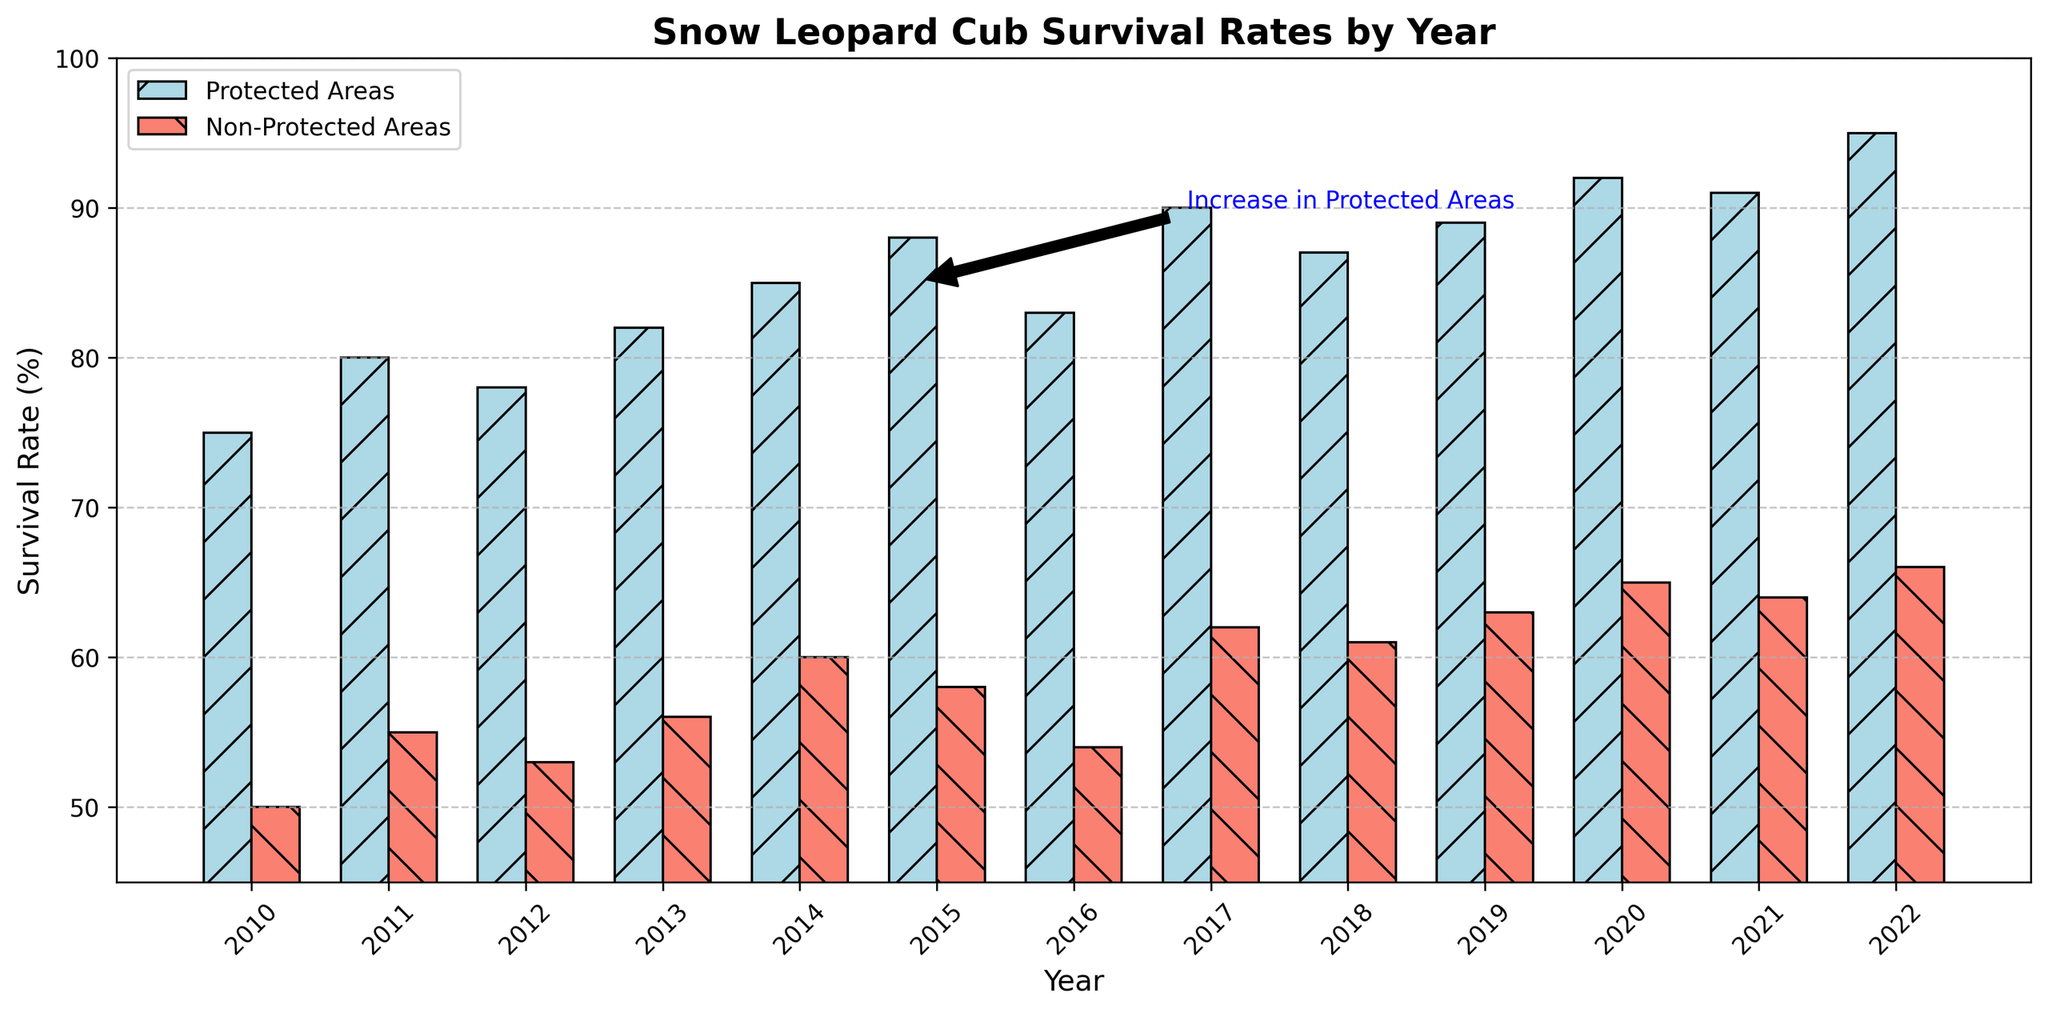What is the survival rate of snow leopard cubs in protected areas in 2015? Look at the bar that represents protected areas for the year 2015. The height of the bar indicates the survival rate.
Answer: 88 How much higher is the survival rate in protected areas compared to non-protected areas in 2022? Find the survival rates for both protected and non-protected areas in 2022. Subtract the non-protected rate from the protected rate to find the difference. 95 (protected) - 66 (non-protected) = 29
Answer: 29 Identify the year with the highest survival rate in non-protected areas. Compare the heights of the bars for non-protected areas across all years. The tallest bar corresponds to the highest survival rate.
Answer: 2022 What is the average survival rate in non-protected areas from 2010 to 2015? Sum the survival rates in non-protected areas for the years 2010 through 2015, then divide by the number of years (6). (50 + 55 + 53 + 56 + 60 + 58) / 6 = 55.333
Answer: 55.33 Which year saw the greatest increase in survival rate in protected areas compared to the previous year? Calculate the year-on-year differences in survival rates for protected areas and identify the year with the largest increase. (80-75=5, 78-80=-2, 82-78=4, 85-82=3, 88-85=3, 83-88=-5, 90-83=7, 87-90=-3, 89-87=2, 92-89=3, 91-92=-1, 95-91=4). The greatest increase is 7, which happened in 2017.
Answer: 2017 What visual element indicates general trends in the data? Identify the components such as bars, colors, and annotations that help illustrate trends over the years. The height of the bars indicates survival rates, and colors differentiate between protected and non-protected areas.
Answer: Bar height How does the annotation contribute to interpreting the data? Discuss the purpose of the annotation within the context of the chart. The annotation highlights the overall increase in survival rates in protected areas, drawing attention to a key trend.
Answer: Highlights key trend Compare the survival rates in 2010 and 2020 for protected areas. By how much did it change? Find the survival rates for protected areas in 2010 and 2020. Subtract the survival rate in 2010 from the rate in 2020. 92 (2020) - 75 (2010) = 17
Answer: 17 In which year did non-protected areas have the lowest survival rate? Identify the year with the shortest bar for non-protected areas, indicating the lowest survival rate.
Answer: 2010 What pattern can be observed from the trend lines of both protected and non-protected areas? Describe the general direction the bars take over time for both categories to deduce patterns. Both trends generally increase over the years.
Answer: Increasing trend 